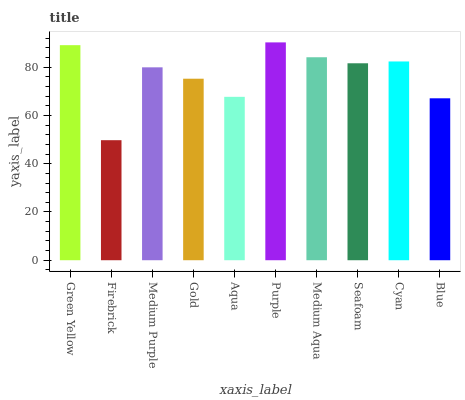Is Firebrick the minimum?
Answer yes or no. Yes. Is Purple the maximum?
Answer yes or no. Yes. Is Medium Purple the minimum?
Answer yes or no. No. Is Medium Purple the maximum?
Answer yes or no. No. Is Medium Purple greater than Firebrick?
Answer yes or no. Yes. Is Firebrick less than Medium Purple?
Answer yes or no. Yes. Is Firebrick greater than Medium Purple?
Answer yes or no. No. Is Medium Purple less than Firebrick?
Answer yes or no. No. Is Seafoam the high median?
Answer yes or no. Yes. Is Medium Purple the low median?
Answer yes or no. Yes. Is Aqua the high median?
Answer yes or no. No. Is Gold the low median?
Answer yes or no. No. 